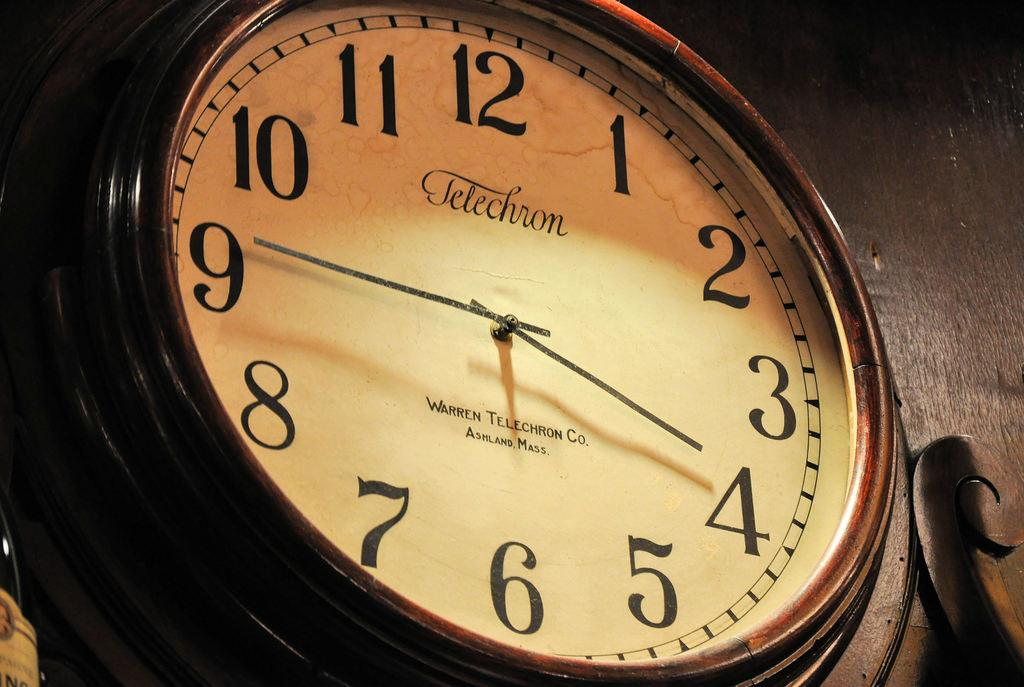<image>
Create a compact narrative representing the image presented. A clock has the brand name Telechron on the face. 